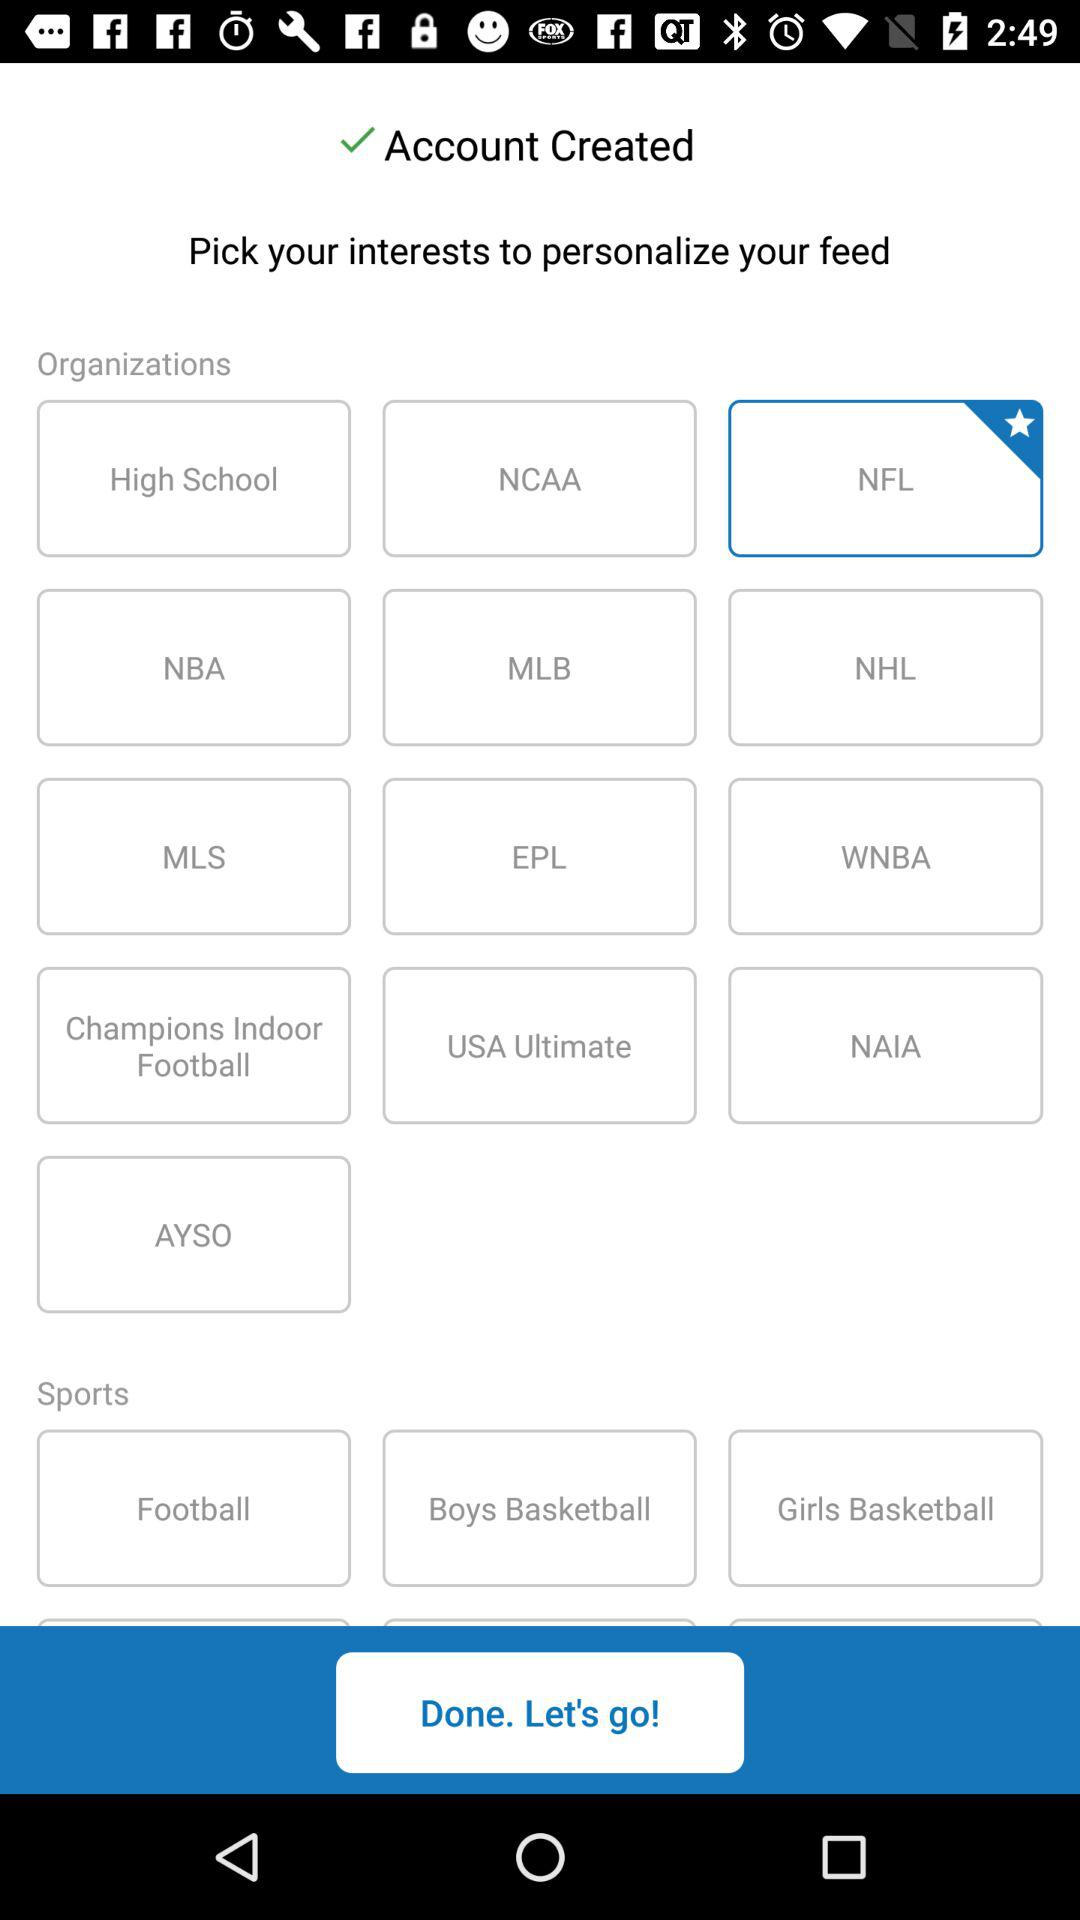What options are available for organizations? The options are "High School", "NCAA", "NFL", "NBA", "MLB", "NHL", "MLS", "EPL", "WNBA", "Champions Indoor Football", "USA Ultimate", "USA Ultimate", "NAIA" and "AYSO". 